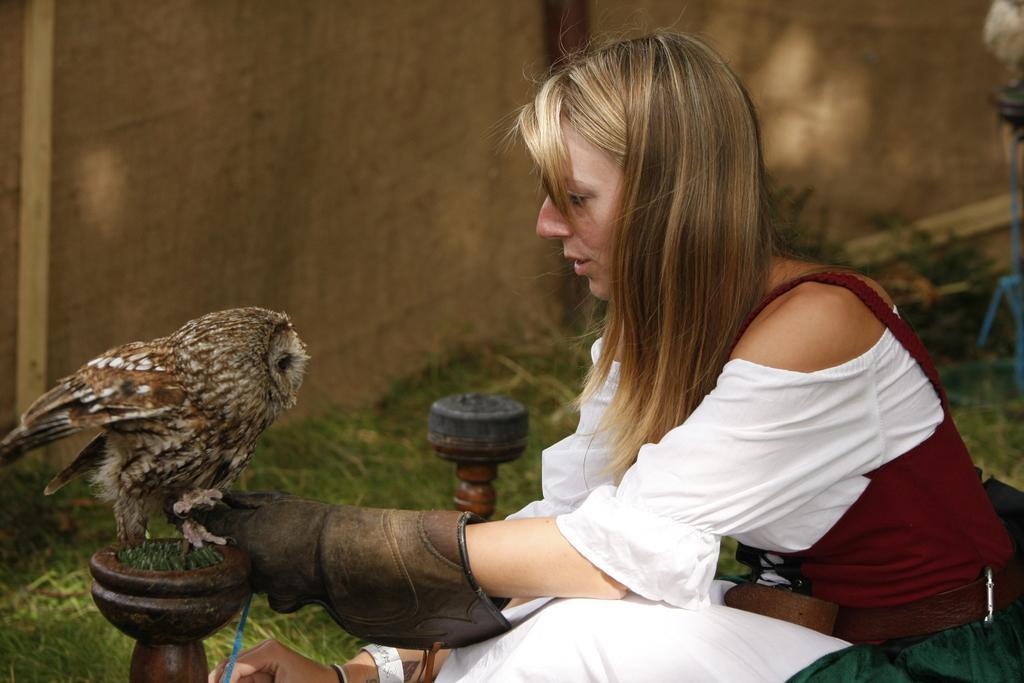In one or two sentences, can you explain what this image depicts? In this image there is a lady sitting, in front of her there is an owl and there are two objects, in the background it is dark. 